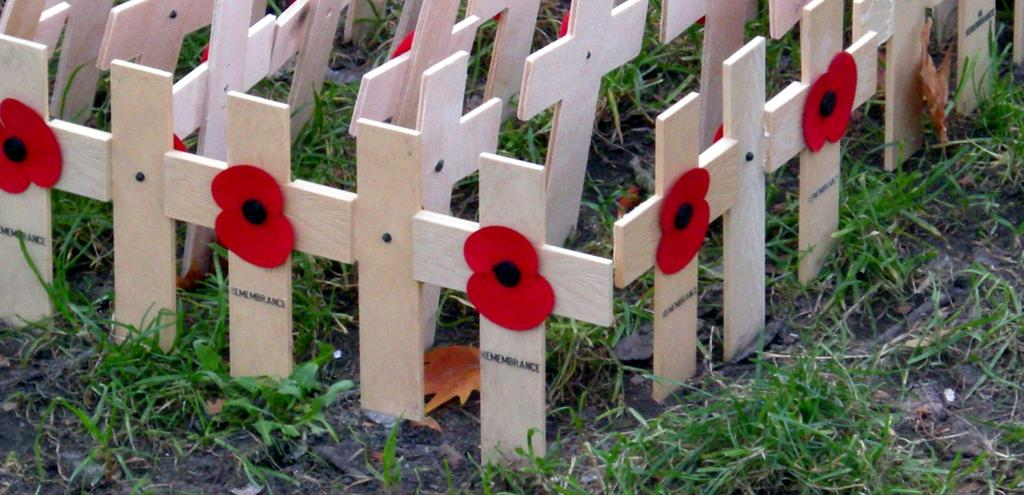What type of material is used to make the plus symbol boards in the image? The plus symbol boards in the image are made of wood. What is the color and texture of the ground in the image? The ground in the image is green and appears to be grass. Is there a glass volcano visible in the image? No, there is no glass volcano present in the image. 